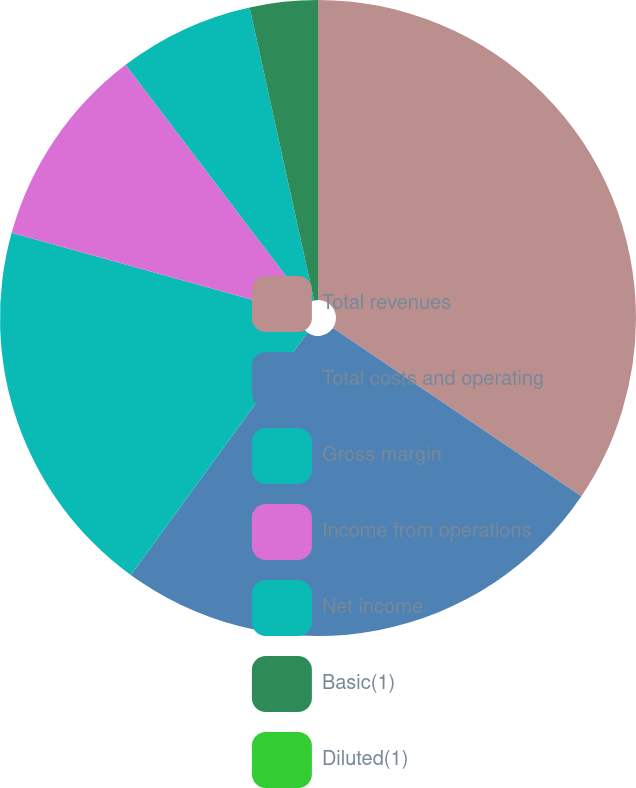Convert chart to OTSL. <chart><loc_0><loc_0><loc_500><loc_500><pie_chart><fcel>Total revenues<fcel>Total costs and operating<fcel>Gross margin<fcel>Income from operations<fcel>Net income<fcel>Basic(1)<fcel>Diluted(1)<nl><fcel>34.47%<fcel>25.55%<fcel>19.3%<fcel>10.34%<fcel>6.89%<fcel>3.45%<fcel>0.0%<nl></chart> 